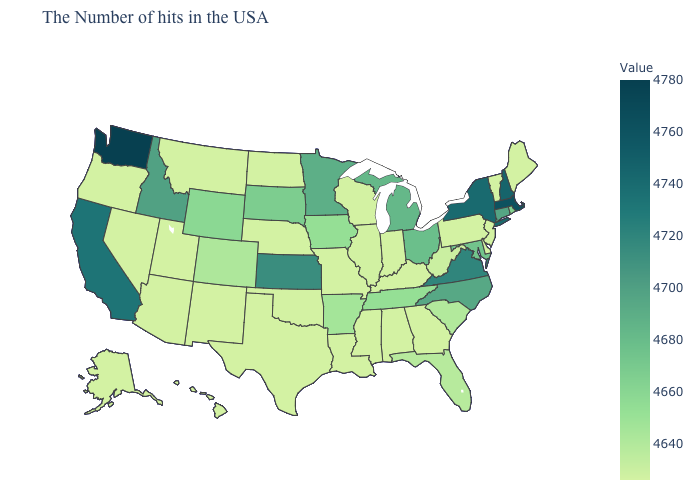Among the states that border Colorado , which have the highest value?
Be succinct. Kansas. Does the map have missing data?
Be succinct. No. Which states have the highest value in the USA?
Write a very short answer. Washington. Does Wyoming have the lowest value in the USA?
Concise answer only. No. Does South Carolina have the lowest value in the USA?
Short answer required. No. Among the states that border Kentucky , does Illinois have the lowest value?
Short answer required. No. Among the states that border Idaho , does Oregon have the highest value?
Short answer required. No. 